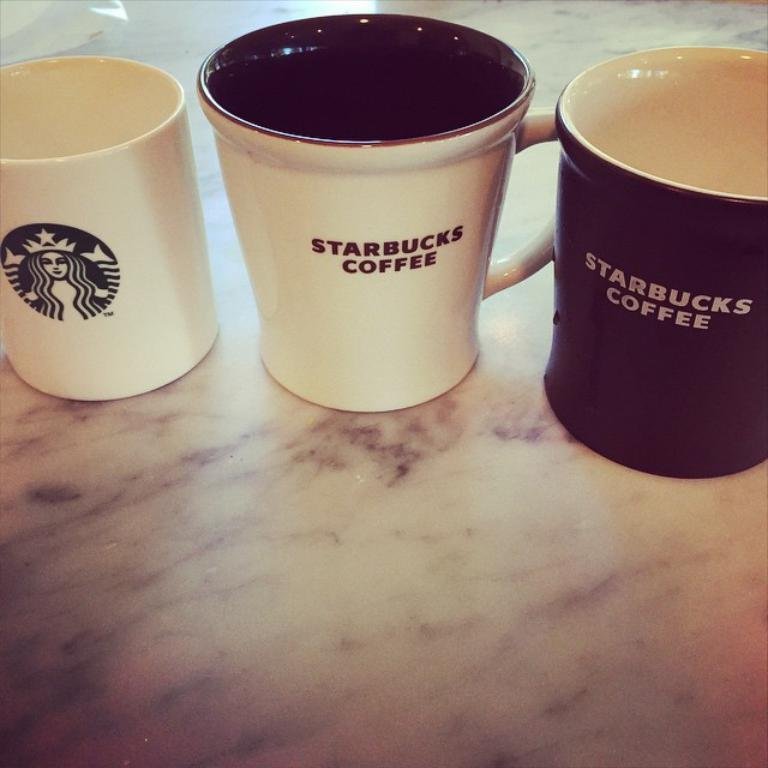How many coffee cups are visible in the image? There are three coffee cups in the image. What is the color of the object on which the coffee cups are placed? The coffee cups are on a white object. What can be found on the surface of the coffee cups? There is text and a logo on the coffee cups. What type of zephyr is blowing through the coffee cups in the image? There is no zephyr present in the image, as a zephyr refers to a gentle breeze, and the image does not depict any wind or breeze. 